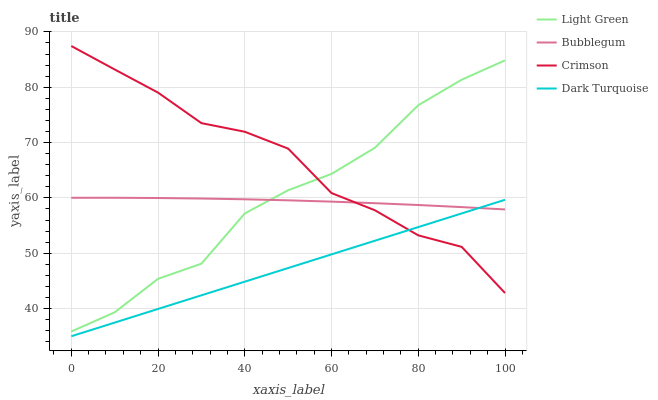Does Dark Turquoise have the minimum area under the curve?
Answer yes or no. Yes. Does Crimson have the maximum area under the curve?
Answer yes or no. Yes. Does Bubblegum have the minimum area under the curve?
Answer yes or no. No. Does Bubblegum have the maximum area under the curve?
Answer yes or no. No. Is Dark Turquoise the smoothest?
Answer yes or no. Yes. Is Light Green the roughest?
Answer yes or no. Yes. Is Bubblegum the smoothest?
Answer yes or no. No. Is Bubblegum the roughest?
Answer yes or no. No. Does Dark Turquoise have the lowest value?
Answer yes or no. Yes. Does Bubblegum have the lowest value?
Answer yes or no. No. Does Crimson have the highest value?
Answer yes or no. Yes. Does Bubblegum have the highest value?
Answer yes or no. No. Is Dark Turquoise less than Light Green?
Answer yes or no. Yes. Is Light Green greater than Dark Turquoise?
Answer yes or no. Yes. Does Crimson intersect Dark Turquoise?
Answer yes or no. Yes. Is Crimson less than Dark Turquoise?
Answer yes or no. No. Is Crimson greater than Dark Turquoise?
Answer yes or no. No. Does Dark Turquoise intersect Light Green?
Answer yes or no. No. 